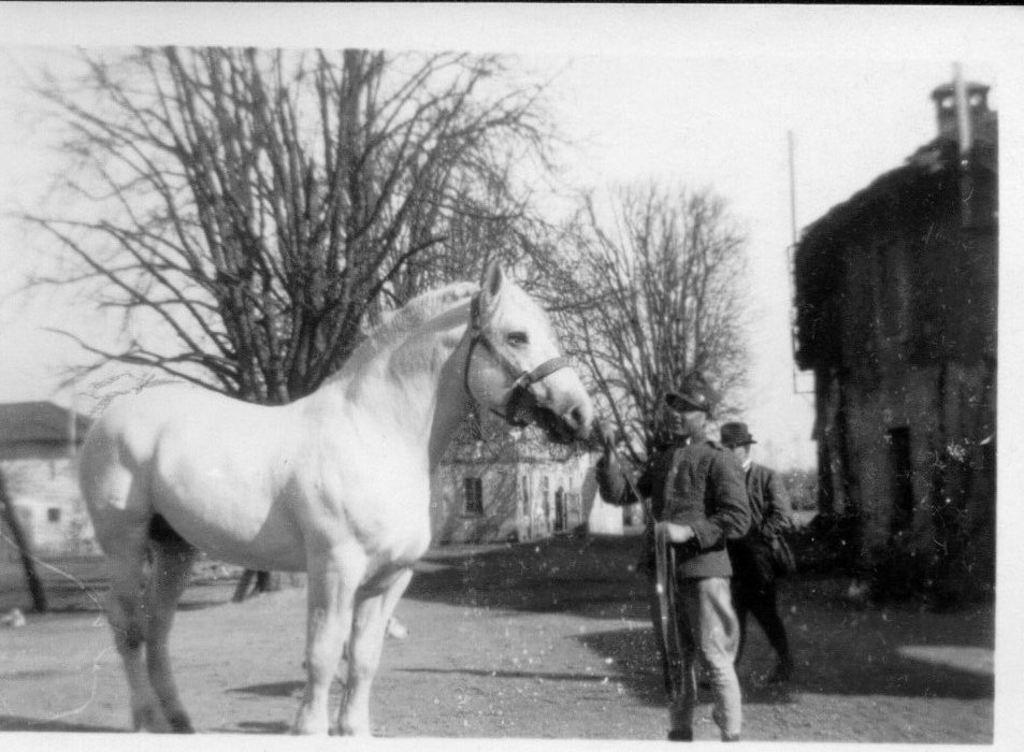What animal is present in the image? There is a horse in the image. How is the horse being controlled or guided in the image? A man is holding the horse with a leash. Can you describe the person walking behind the horse? There is a person walking behind the horse. What type of structure can be seen in the image? There is a building in the image. What natural elements are visible in the image? There are trees and the sky visible in the image. How does the horse increase its speed while walking with the flock? There is no flock present in the image, and the horse's speed is not mentioned or depicted. 